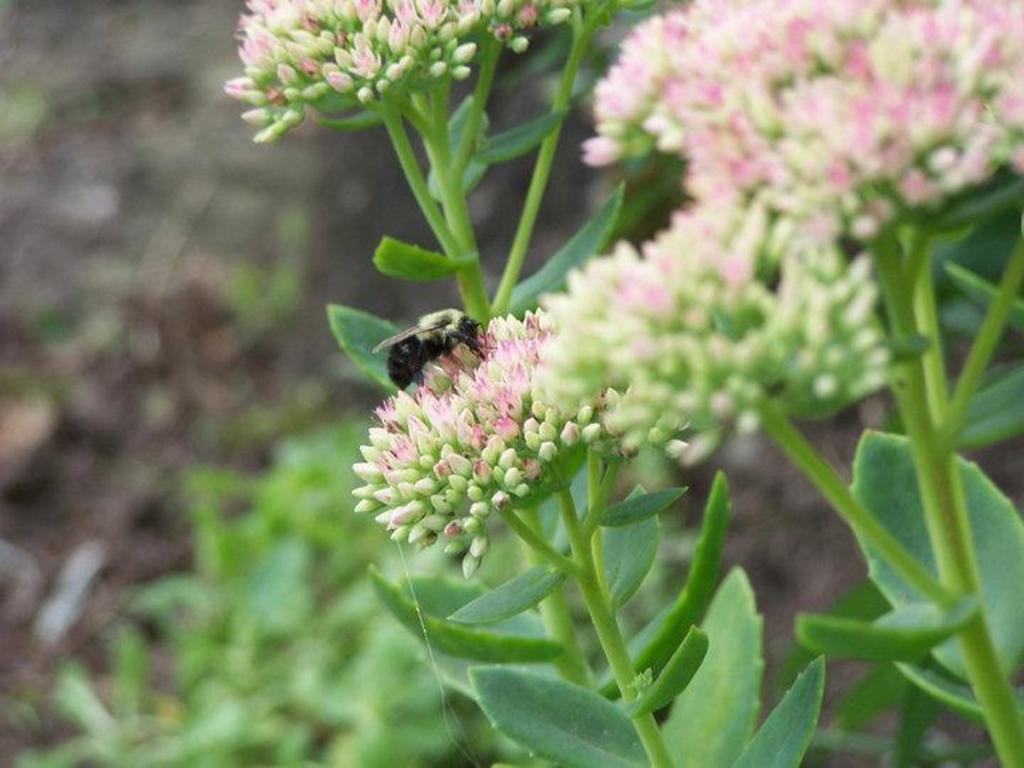Could you give a brief overview of what you see in this image? In this image I can see flowers, green colour leaves and here I can see a black colour insect. I can also see this image is little bit blurry from background. 